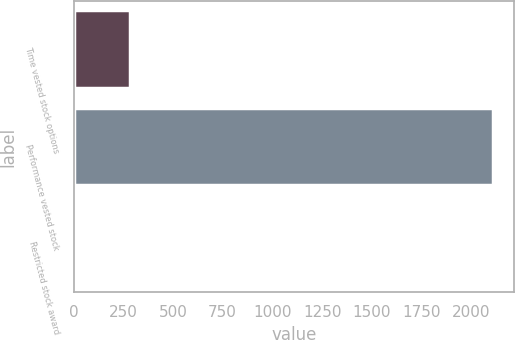<chart> <loc_0><loc_0><loc_500><loc_500><bar_chart><fcel>Time vested stock options<fcel>Performance vested stock<fcel>Restricted stock award<nl><fcel>284<fcel>2109<fcel>10<nl></chart> 